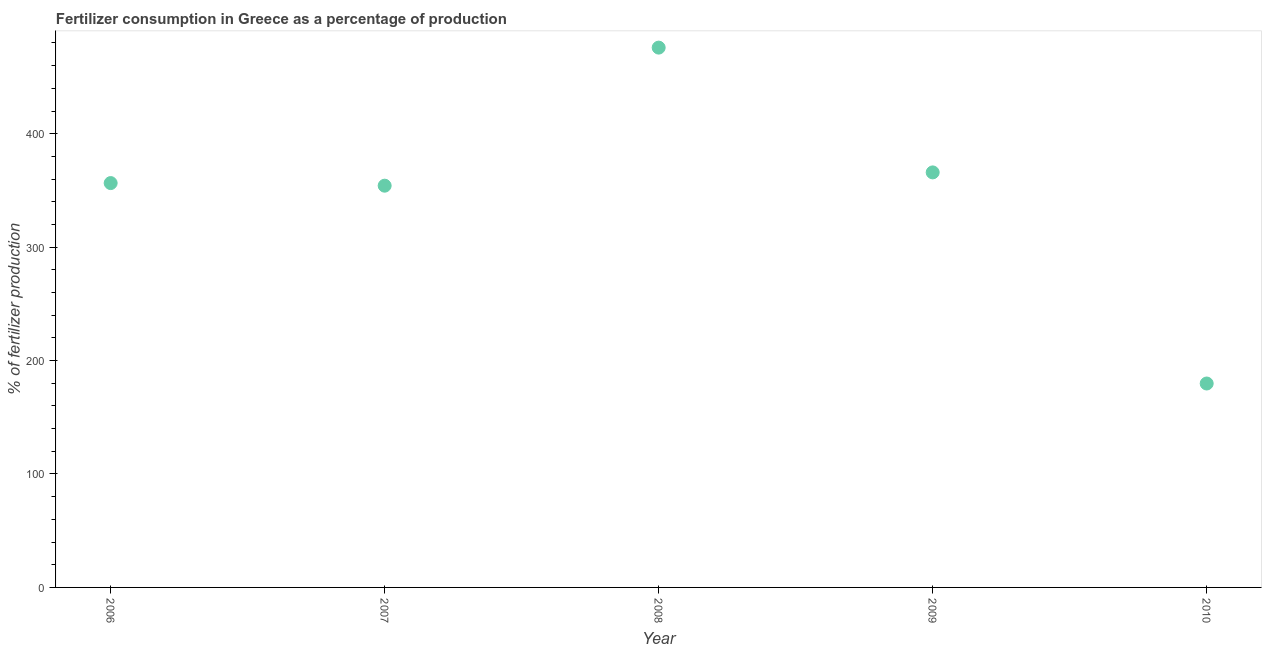What is the amount of fertilizer consumption in 2007?
Give a very brief answer. 354.17. Across all years, what is the maximum amount of fertilizer consumption?
Make the answer very short. 475.89. Across all years, what is the minimum amount of fertilizer consumption?
Your answer should be compact. 179.77. What is the sum of the amount of fertilizer consumption?
Keep it short and to the point. 1732.2. What is the difference between the amount of fertilizer consumption in 2008 and 2010?
Your answer should be very brief. 296.12. What is the average amount of fertilizer consumption per year?
Provide a succinct answer. 346.44. What is the median amount of fertilizer consumption?
Offer a very short reply. 356.47. In how many years, is the amount of fertilizer consumption greater than 220 %?
Your answer should be compact. 4. Do a majority of the years between 2007 and 2010 (inclusive) have amount of fertilizer consumption greater than 400 %?
Provide a short and direct response. No. What is the ratio of the amount of fertilizer consumption in 2006 to that in 2007?
Your answer should be very brief. 1.01. Is the amount of fertilizer consumption in 2007 less than that in 2009?
Keep it short and to the point. Yes. Is the difference between the amount of fertilizer consumption in 2009 and 2010 greater than the difference between any two years?
Provide a short and direct response. No. What is the difference between the highest and the second highest amount of fertilizer consumption?
Provide a succinct answer. 110. Is the sum of the amount of fertilizer consumption in 2007 and 2009 greater than the maximum amount of fertilizer consumption across all years?
Ensure brevity in your answer.  Yes. What is the difference between the highest and the lowest amount of fertilizer consumption?
Your answer should be compact. 296.12. In how many years, is the amount of fertilizer consumption greater than the average amount of fertilizer consumption taken over all years?
Offer a terse response. 4. Does the amount of fertilizer consumption monotonically increase over the years?
Offer a terse response. No. How many dotlines are there?
Keep it short and to the point. 1. Are the values on the major ticks of Y-axis written in scientific E-notation?
Provide a short and direct response. No. Does the graph contain any zero values?
Ensure brevity in your answer.  No. Does the graph contain grids?
Provide a short and direct response. No. What is the title of the graph?
Your response must be concise. Fertilizer consumption in Greece as a percentage of production. What is the label or title of the X-axis?
Provide a short and direct response. Year. What is the label or title of the Y-axis?
Provide a succinct answer. % of fertilizer production. What is the % of fertilizer production in 2006?
Provide a short and direct response. 356.47. What is the % of fertilizer production in 2007?
Ensure brevity in your answer.  354.17. What is the % of fertilizer production in 2008?
Provide a short and direct response. 475.89. What is the % of fertilizer production in 2009?
Make the answer very short. 365.89. What is the % of fertilizer production in 2010?
Your answer should be compact. 179.77. What is the difference between the % of fertilizer production in 2006 and 2007?
Keep it short and to the point. 2.3. What is the difference between the % of fertilizer production in 2006 and 2008?
Offer a very short reply. -119.42. What is the difference between the % of fertilizer production in 2006 and 2009?
Provide a short and direct response. -9.42. What is the difference between the % of fertilizer production in 2006 and 2010?
Keep it short and to the point. 176.7. What is the difference between the % of fertilizer production in 2007 and 2008?
Provide a short and direct response. -121.72. What is the difference between the % of fertilizer production in 2007 and 2009?
Provide a short and direct response. -11.71. What is the difference between the % of fertilizer production in 2007 and 2010?
Offer a very short reply. 174.4. What is the difference between the % of fertilizer production in 2008 and 2009?
Provide a succinct answer. 110. What is the difference between the % of fertilizer production in 2008 and 2010?
Your response must be concise. 296.12. What is the difference between the % of fertilizer production in 2009 and 2010?
Your answer should be very brief. 186.12. What is the ratio of the % of fertilizer production in 2006 to that in 2008?
Provide a short and direct response. 0.75. What is the ratio of the % of fertilizer production in 2006 to that in 2009?
Provide a succinct answer. 0.97. What is the ratio of the % of fertilizer production in 2006 to that in 2010?
Your answer should be very brief. 1.98. What is the ratio of the % of fertilizer production in 2007 to that in 2008?
Your response must be concise. 0.74. What is the ratio of the % of fertilizer production in 2007 to that in 2010?
Offer a terse response. 1.97. What is the ratio of the % of fertilizer production in 2008 to that in 2009?
Make the answer very short. 1.3. What is the ratio of the % of fertilizer production in 2008 to that in 2010?
Ensure brevity in your answer.  2.65. What is the ratio of the % of fertilizer production in 2009 to that in 2010?
Offer a very short reply. 2.04. 